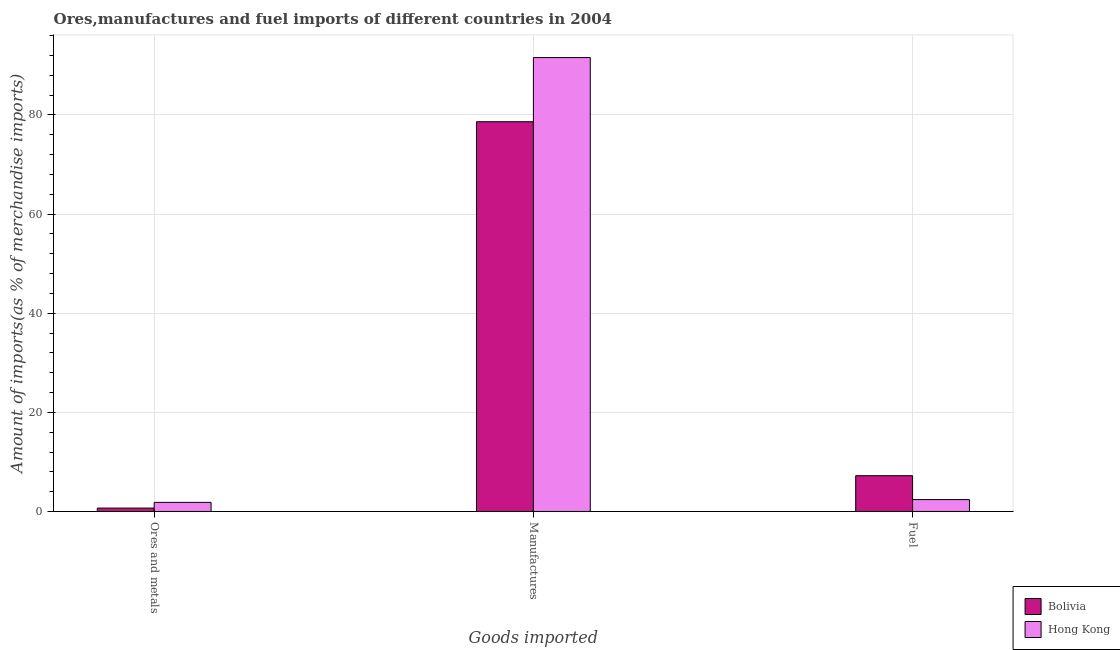How many different coloured bars are there?
Give a very brief answer. 2. How many groups of bars are there?
Ensure brevity in your answer.  3. Are the number of bars per tick equal to the number of legend labels?
Provide a short and direct response. Yes. Are the number of bars on each tick of the X-axis equal?
Ensure brevity in your answer.  Yes. What is the label of the 3rd group of bars from the left?
Give a very brief answer. Fuel. What is the percentage of fuel imports in Bolivia?
Provide a succinct answer. 7.22. Across all countries, what is the maximum percentage of ores and metals imports?
Offer a terse response. 1.84. Across all countries, what is the minimum percentage of manufactures imports?
Offer a very short reply. 78.63. In which country was the percentage of fuel imports maximum?
Your answer should be compact. Bolivia. In which country was the percentage of ores and metals imports minimum?
Your answer should be compact. Bolivia. What is the total percentage of manufactures imports in the graph?
Your answer should be very brief. 170.21. What is the difference between the percentage of ores and metals imports in Hong Kong and that in Bolivia?
Offer a very short reply. 1.15. What is the difference between the percentage of ores and metals imports in Bolivia and the percentage of manufactures imports in Hong Kong?
Provide a short and direct response. -90.89. What is the average percentage of fuel imports per country?
Your response must be concise. 4.81. What is the difference between the percentage of ores and metals imports and percentage of manufactures imports in Hong Kong?
Keep it short and to the point. -89.74. In how many countries, is the percentage of manufactures imports greater than 68 %?
Offer a terse response. 2. What is the ratio of the percentage of manufactures imports in Bolivia to that in Hong Kong?
Give a very brief answer. 0.86. Is the difference between the percentage of fuel imports in Hong Kong and Bolivia greater than the difference between the percentage of manufactures imports in Hong Kong and Bolivia?
Your response must be concise. No. What is the difference between the highest and the second highest percentage of manufactures imports?
Ensure brevity in your answer.  12.94. What is the difference between the highest and the lowest percentage of fuel imports?
Ensure brevity in your answer.  4.82. In how many countries, is the percentage of manufactures imports greater than the average percentage of manufactures imports taken over all countries?
Provide a succinct answer. 1. Is the sum of the percentage of ores and metals imports in Hong Kong and Bolivia greater than the maximum percentage of manufactures imports across all countries?
Offer a terse response. No. What does the 1st bar from the left in Manufactures represents?
Ensure brevity in your answer.  Bolivia. What does the 1st bar from the right in Fuel represents?
Your answer should be very brief. Hong Kong. Is it the case that in every country, the sum of the percentage of ores and metals imports and percentage of manufactures imports is greater than the percentage of fuel imports?
Make the answer very short. Yes. How many countries are there in the graph?
Provide a succinct answer. 2. What is the difference between two consecutive major ticks on the Y-axis?
Your answer should be compact. 20. Where does the legend appear in the graph?
Provide a succinct answer. Bottom right. What is the title of the graph?
Provide a short and direct response. Ores,manufactures and fuel imports of different countries in 2004. What is the label or title of the X-axis?
Your answer should be compact. Goods imported. What is the label or title of the Y-axis?
Provide a succinct answer. Amount of imports(as % of merchandise imports). What is the Amount of imports(as % of merchandise imports) in Bolivia in Ores and metals?
Your answer should be very brief. 0.68. What is the Amount of imports(as % of merchandise imports) of Hong Kong in Ores and metals?
Provide a succinct answer. 1.84. What is the Amount of imports(as % of merchandise imports) in Bolivia in Manufactures?
Your answer should be compact. 78.63. What is the Amount of imports(as % of merchandise imports) in Hong Kong in Manufactures?
Your answer should be very brief. 91.57. What is the Amount of imports(as % of merchandise imports) in Bolivia in Fuel?
Your answer should be compact. 7.22. What is the Amount of imports(as % of merchandise imports) in Hong Kong in Fuel?
Offer a terse response. 2.4. Across all Goods imported, what is the maximum Amount of imports(as % of merchandise imports) of Bolivia?
Your answer should be compact. 78.63. Across all Goods imported, what is the maximum Amount of imports(as % of merchandise imports) of Hong Kong?
Provide a short and direct response. 91.57. Across all Goods imported, what is the minimum Amount of imports(as % of merchandise imports) in Bolivia?
Your answer should be compact. 0.68. Across all Goods imported, what is the minimum Amount of imports(as % of merchandise imports) in Hong Kong?
Ensure brevity in your answer.  1.84. What is the total Amount of imports(as % of merchandise imports) of Bolivia in the graph?
Ensure brevity in your answer.  86.54. What is the total Amount of imports(as % of merchandise imports) of Hong Kong in the graph?
Your answer should be very brief. 95.81. What is the difference between the Amount of imports(as % of merchandise imports) in Bolivia in Ores and metals and that in Manufactures?
Offer a very short reply. -77.95. What is the difference between the Amount of imports(as % of merchandise imports) in Hong Kong in Ores and metals and that in Manufactures?
Provide a short and direct response. -89.74. What is the difference between the Amount of imports(as % of merchandise imports) of Bolivia in Ores and metals and that in Fuel?
Keep it short and to the point. -6.54. What is the difference between the Amount of imports(as % of merchandise imports) in Hong Kong in Ores and metals and that in Fuel?
Provide a short and direct response. -0.56. What is the difference between the Amount of imports(as % of merchandise imports) of Bolivia in Manufactures and that in Fuel?
Your answer should be very brief. 71.41. What is the difference between the Amount of imports(as % of merchandise imports) of Hong Kong in Manufactures and that in Fuel?
Keep it short and to the point. 89.18. What is the difference between the Amount of imports(as % of merchandise imports) in Bolivia in Ores and metals and the Amount of imports(as % of merchandise imports) in Hong Kong in Manufactures?
Your answer should be compact. -90.89. What is the difference between the Amount of imports(as % of merchandise imports) of Bolivia in Ores and metals and the Amount of imports(as % of merchandise imports) of Hong Kong in Fuel?
Your answer should be very brief. -1.72. What is the difference between the Amount of imports(as % of merchandise imports) of Bolivia in Manufactures and the Amount of imports(as % of merchandise imports) of Hong Kong in Fuel?
Offer a terse response. 76.23. What is the average Amount of imports(as % of merchandise imports) in Bolivia per Goods imported?
Provide a succinct answer. 28.85. What is the average Amount of imports(as % of merchandise imports) of Hong Kong per Goods imported?
Offer a very short reply. 31.94. What is the difference between the Amount of imports(as % of merchandise imports) in Bolivia and Amount of imports(as % of merchandise imports) in Hong Kong in Ores and metals?
Make the answer very short. -1.15. What is the difference between the Amount of imports(as % of merchandise imports) in Bolivia and Amount of imports(as % of merchandise imports) in Hong Kong in Manufactures?
Offer a very short reply. -12.94. What is the difference between the Amount of imports(as % of merchandise imports) in Bolivia and Amount of imports(as % of merchandise imports) in Hong Kong in Fuel?
Your answer should be very brief. 4.82. What is the ratio of the Amount of imports(as % of merchandise imports) of Bolivia in Ores and metals to that in Manufactures?
Your answer should be compact. 0.01. What is the ratio of the Amount of imports(as % of merchandise imports) of Hong Kong in Ores and metals to that in Manufactures?
Ensure brevity in your answer.  0.02. What is the ratio of the Amount of imports(as % of merchandise imports) in Bolivia in Ores and metals to that in Fuel?
Your response must be concise. 0.09. What is the ratio of the Amount of imports(as % of merchandise imports) in Hong Kong in Ores and metals to that in Fuel?
Your answer should be very brief. 0.77. What is the ratio of the Amount of imports(as % of merchandise imports) in Bolivia in Manufactures to that in Fuel?
Offer a very short reply. 10.89. What is the ratio of the Amount of imports(as % of merchandise imports) of Hong Kong in Manufactures to that in Fuel?
Make the answer very short. 38.17. What is the difference between the highest and the second highest Amount of imports(as % of merchandise imports) in Bolivia?
Ensure brevity in your answer.  71.41. What is the difference between the highest and the second highest Amount of imports(as % of merchandise imports) of Hong Kong?
Keep it short and to the point. 89.18. What is the difference between the highest and the lowest Amount of imports(as % of merchandise imports) of Bolivia?
Your answer should be compact. 77.95. What is the difference between the highest and the lowest Amount of imports(as % of merchandise imports) of Hong Kong?
Make the answer very short. 89.74. 